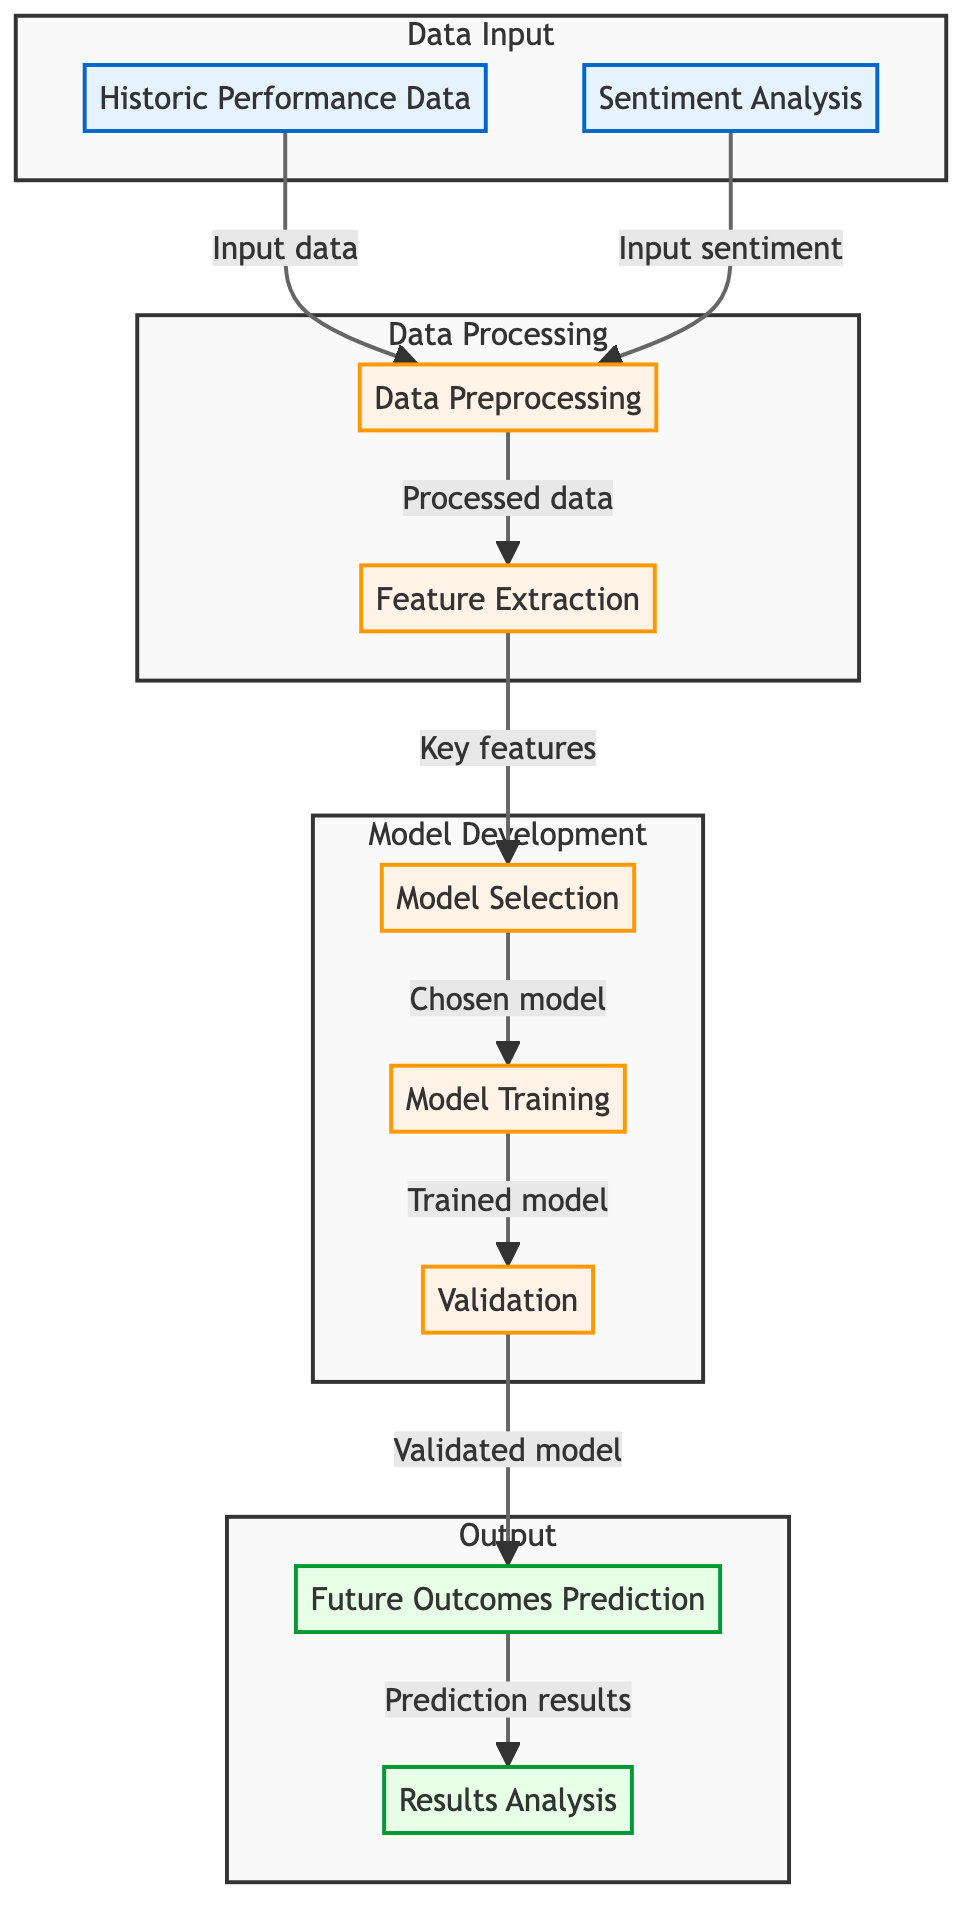What are the two main inputs to the diagram? The diagram shows two main inputs: "Historic Performance Data" and "Sentiment Analysis." These are indicated at the start of the flow as distinct nodes leading to the Data Processing step.
Answer: Historic Performance Data, Sentiment Analysis Which step comes after "Data Preprocessing"? In the flow, after "Data Preprocessing," the next step is "Feature Extraction." This is made clear by the directed arrow leading from one process node to the next.
Answer: Feature Extraction How many subgraphs are in the diagram? There are four subgraphs in the diagram: Data Input, Data Processing, Model Development, and Output. Each subgraph groups related nodes together to show their functional relationship.
Answer: Four What is the final outcome of the process? The final outcome indicated in the diagram is "Results Analysis," which follows the prediction stage as the last step in the flow.
Answer: Results Analysis What connects "Model Selection" to "Model Training"? The connection between "Model Selection" and "Model Training" is represented by a directed arrow labeled "Chosen model," indicating that the selected model moves on to the training stage.
Answer: Chosen model How many stages are involved in the model development process? In the diagram, the model development process involves three stages: Model Selection, Training, and Validation, which are grouped under the Model Development subgraph.
Answer: Three Which node outputs "Prediction results"? The node that outputs "Prediction results" is "Future Outcomes Prediction." This node is positioned before "Results Analysis," indicating its role in the process.
Answer: Future Outcomes Prediction What type of analysis is performed on the input data? The input data undergoes "Data Preprocessing," which prepares it for further processing and analysis. This step is crucial for ensuring the data is suitable for subsequent processing.
Answer: Data Preprocessing Which step analyzes the results of the predictions? The step that analyzes the results of the predictions is called "Results Analysis," located at the end of the diagram indicating it is the final evaluation phase.
Answer: Results Analysis 